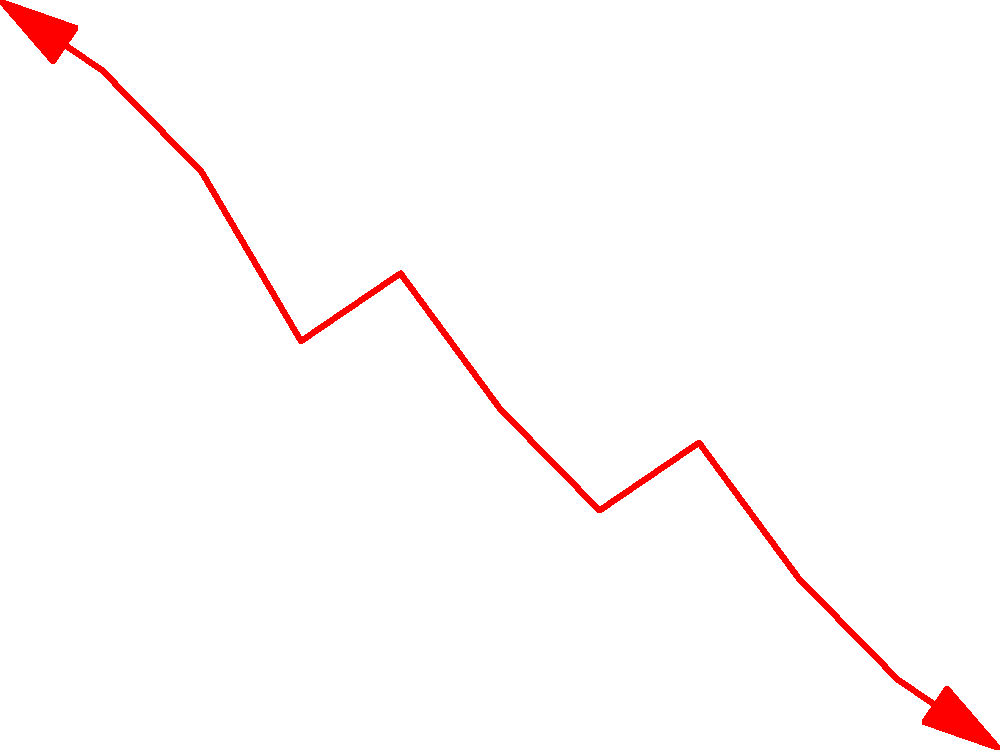Based on the trend shown in the graph, what critical observation can be made about the NHS patient satisfaction ratings from 2010 to 2020, and what might this suggest about the performance of the NHS over this period? To answer this question, we need to analyze the trend in the graph step-by-step:

1. Starting point: In 2010, the patient satisfaction rating was at its highest at 70%.

2. Overall trend: There is a clear downward trend from 2010 to 2020.

3. Year-by-year analysis:
   - 2010-2013: Sharp decline from 70% to 60%
   - 2013-2014: Slight increase to 62%
   - 2014-2016: Another sharp decline to 55%
   - 2016-2017: Small increase to 57%
   - 2017-2020: Continuous decline to 48%

4. Total change: Over the decade, patient satisfaction dropped from 70% to 48%, a decrease of 22 percentage points.

5. Consistency: Despite minor fluctuations, the overall trend is consistently downward.

6. Rate of decline: The rate of decline appears to be steeper in the earlier years (2010-2013) and the later years (2017-2020).

This downward trend suggests a significant and consistent deterioration in patient satisfaction with NHS services over the decade. It may indicate systemic issues within the NHS, such as increased waiting times, reduced quality of care, or resource constraints. The persistence of this trend, despite minor improvements in some years, points to a failure to address underlying problems effectively.
Answer: Consistent decline in NHS patient satisfaction from 70% to 48% over 2010-2020, suggesting deteriorating performance and unresolved systemic issues. 